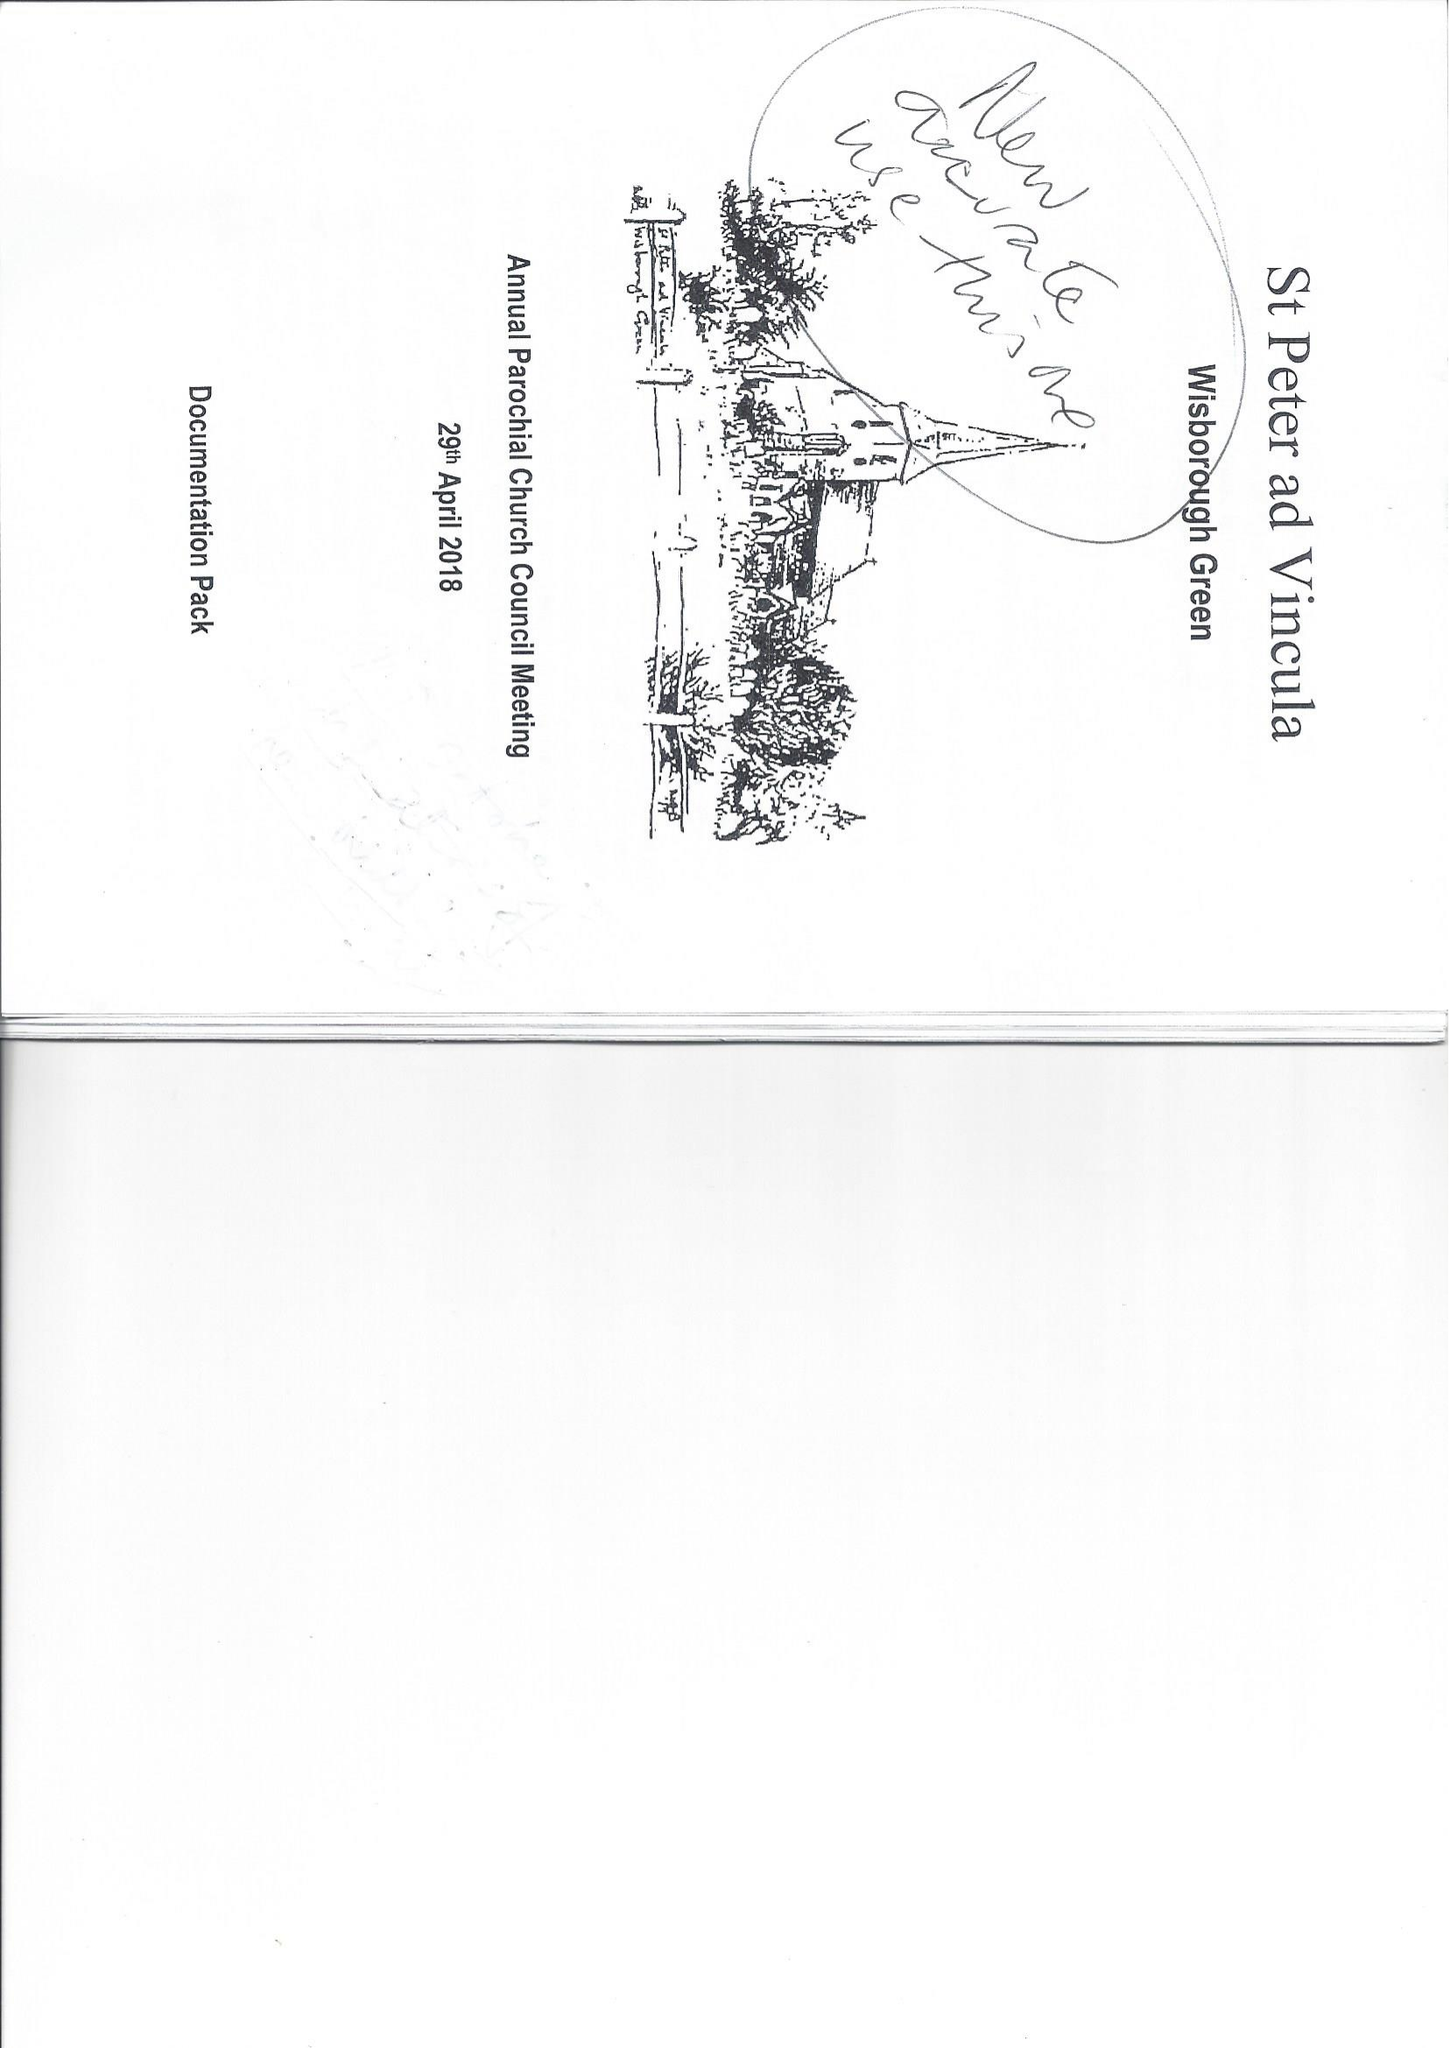What is the value for the address__post_town?
Answer the question using a single word or phrase. BILLINGSHURST 